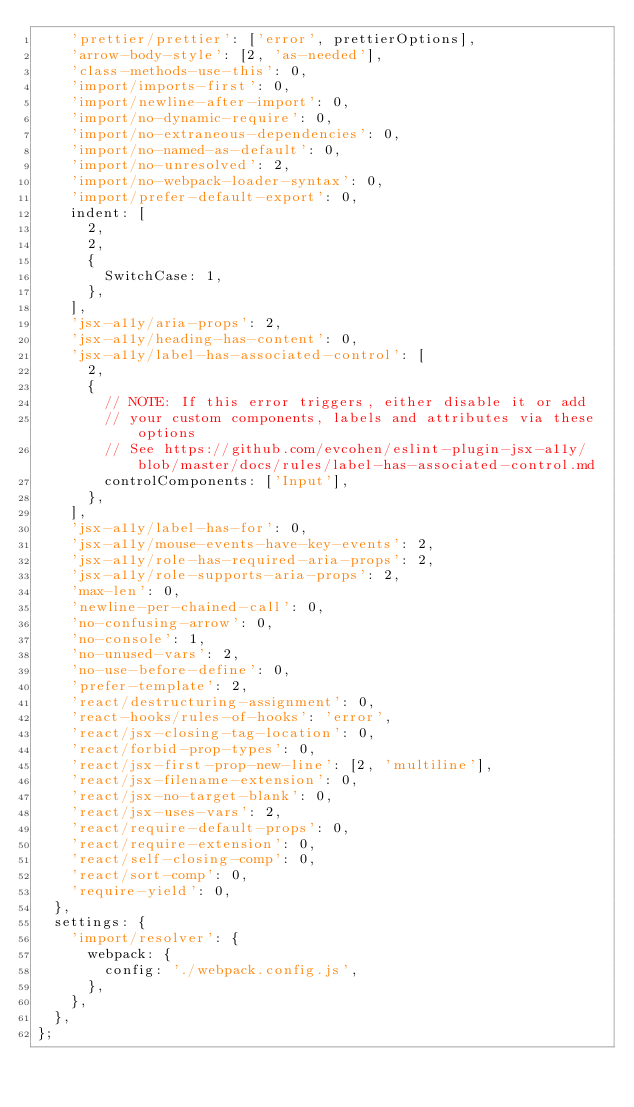<code> <loc_0><loc_0><loc_500><loc_500><_JavaScript_>    'prettier/prettier': ['error', prettierOptions],
    'arrow-body-style': [2, 'as-needed'],
    'class-methods-use-this': 0,
    'import/imports-first': 0,
    'import/newline-after-import': 0,
    'import/no-dynamic-require': 0,
    'import/no-extraneous-dependencies': 0,
    'import/no-named-as-default': 0,
    'import/no-unresolved': 2,
    'import/no-webpack-loader-syntax': 0,
    'import/prefer-default-export': 0,
    indent: [
      2,
      2,
      {
        SwitchCase: 1,
      },
    ],
    'jsx-a11y/aria-props': 2,
    'jsx-a11y/heading-has-content': 0,
    'jsx-a11y/label-has-associated-control': [
      2,
      {
        // NOTE: If this error triggers, either disable it or add
        // your custom components, labels and attributes via these options
        // See https://github.com/evcohen/eslint-plugin-jsx-a11y/blob/master/docs/rules/label-has-associated-control.md
        controlComponents: ['Input'],
      },
    ],
    'jsx-a11y/label-has-for': 0,
    'jsx-a11y/mouse-events-have-key-events': 2,
    'jsx-a11y/role-has-required-aria-props': 2,
    'jsx-a11y/role-supports-aria-props': 2,
    'max-len': 0,
    'newline-per-chained-call': 0,
    'no-confusing-arrow': 0,
    'no-console': 1,
    'no-unused-vars': 2,
    'no-use-before-define': 0,
    'prefer-template': 2,
    'react/destructuring-assignment': 0,
    'react-hooks/rules-of-hooks': 'error',
    'react/jsx-closing-tag-location': 0,
    'react/forbid-prop-types': 0,
    'react/jsx-first-prop-new-line': [2, 'multiline'],
    'react/jsx-filename-extension': 0,
    'react/jsx-no-target-blank': 0,
    'react/jsx-uses-vars': 2,
    'react/require-default-props': 0,
    'react/require-extension': 0,
    'react/self-closing-comp': 0,
    'react/sort-comp': 0,
    'require-yield': 0,
  },
  settings: {
    'import/resolver': {
      webpack: {
        config: './webpack.config.js',
      },
    },
  },
};
</code> 